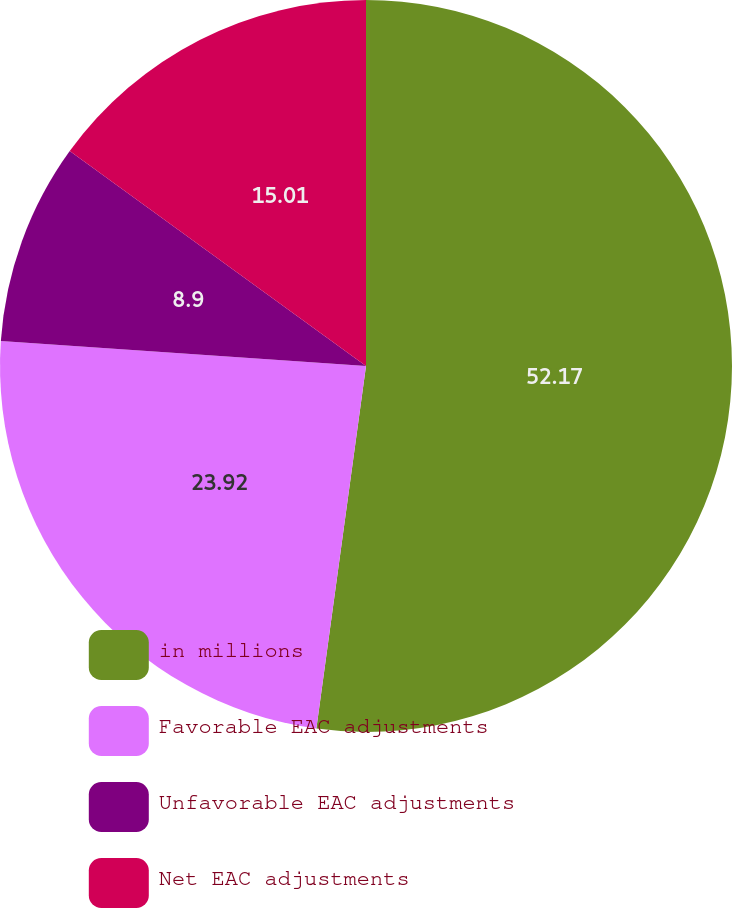Convert chart. <chart><loc_0><loc_0><loc_500><loc_500><pie_chart><fcel>in millions<fcel>Favorable EAC adjustments<fcel>Unfavorable EAC adjustments<fcel>Net EAC adjustments<nl><fcel>52.16%<fcel>23.92%<fcel>8.9%<fcel>15.01%<nl></chart> 